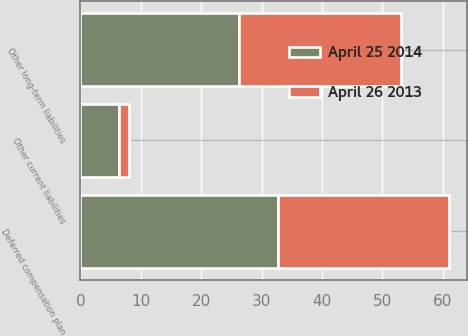Convert chart. <chart><loc_0><loc_0><loc_500><loc_500><stacked_bar_chart><ecel><fcel>Deferred compensation plan<fcel>Other current liabilities<fcel>Other long-term liabilities<nl><fcel>April 25 2014<fcel>32.7<fcel>6.4<fcel>26.3<nl><fcel>April 26 2013<fcel>28.3<fcel>1.6<fcel>26.7<nl></chart> 